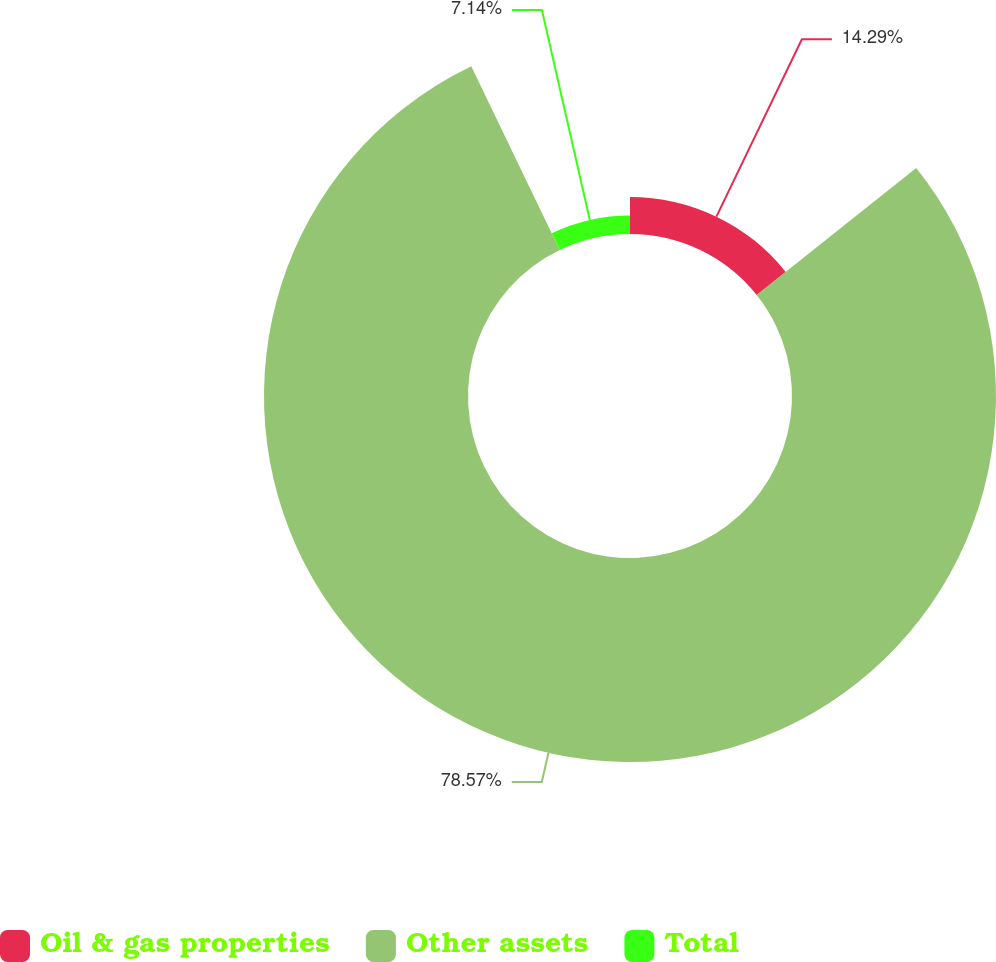<chart> <loc_0><loc_0><loc_500><loc_500><pie_chart><fcel>Oil & gas properties<fcel>Other assets<fcel>Total<nl><fcel>14.29%<fcel>78.57%<fcel>7.14%<nl></chart> 